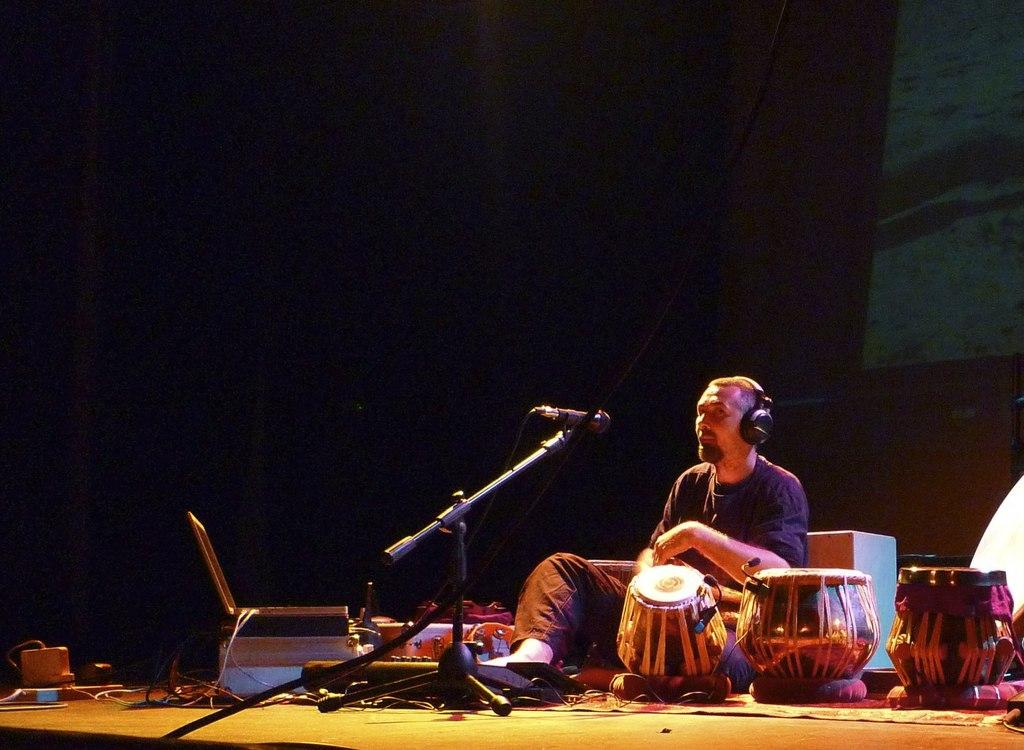What is the person in the image doing? There is a person sitting in the image. What else can be seen in the image besides the person? There are musical instruments and a microphone visible in the image. What might be used for amplifying sound in the image? A microphone is visible in the image. What is on the ground in the image? There are devices on the ground in the image. What is the lighting condition in the image? The background of the image is dark. Can you see any deer in the image? No, there are no deer present in the image. What type of street is visible in the image? There is no street visible in the image. 